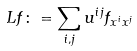Convert formula to latex. <formula><loc_0><loc_0><loc_500><loc_500>L f \colon = \sum _ { i , j } u ^ { i j } f _ { x ^ { i } x ^ { j } }</formula> 